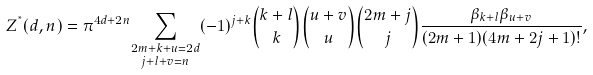<formula> <loc_0><loc_0><loc_500><loc_500>Z ^ { ^ { * } } ( d , n ) = \pi ^ { 4 d + 2 n } \underset { j + l + v = n } { \sum _ { 2 m + k + u = 2 d } } ( - 1 ) ^ { j + k } \binom { k + l } { k } \binom { u + v } { u } \binom { 2 m + j } { j } \frac { \beta _ { k + l } \beta _ { u + v } } { ( 2 m + 1 ) ( 4 m + 2 j + 1 ) ! } ,</formula> 